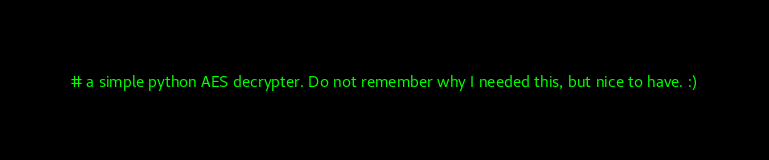<code> <loc_0><loc_0><loc_500><loc_500><_Python_># a simple python AES decrypter. Do not remember why I needed this, but nice to have. :)
</code> 